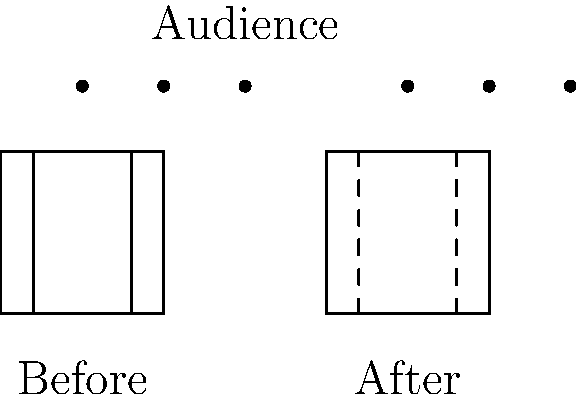Analyze the impact of minimalist set design on the audience's perception of Shakespeare's "Romeo and Juliet". How might the transition from a detailed, period-accurate set (left) to a stripped-down, suggestive design (right) alter the audience's engagement with the play's themes and characters? Consider the potential loss of historical context and the shift in focus to the performers and dialogue. 1. Traditional Set Design (Before):
   - Detailed, period-accurate set with solid walls and defined spaces
   - Provides clear historical context and immersive environment
   - Supports audience's visual understanding of the play's setting

2. Minimalist Set Design (After):
   - Stripped-down design with suggestive, dashed lines
   - Removes specific historical markers and detailed scenery
   - Shifts focus to performers and dialogue

3. Impact on Audience Perception:
   a. Loss of Historical Context:
      - Reduced visual cues may disconnect audience from specific time period
      - Could potentially universalize the story, making it feel more timeless

   b. Increased Focus on Performers:
      - Less visual distraction allows for greater attention to actors
      - May enhance audience's engagement with character emotions and relationships

   c. Emphasis on Dialogue:
      - Minimalist design puts more weight on the spoken word
      - Could heighten audience's attention to Shakespeare's language and poetic devices

   d. Imagination and Interpretation:
      - Sparse set may require audience to fill in gaps with their imagination
      - Could lead to more personal and varied interpretations of the play

   e. Thematic Focus:
      - Removal of period-specific elements might emphasize universal themes
      - Could potentially make the play's messages feel more relevant to contemporary audiences

4. Potential Drawbacks:
   - Risk of losing the play's intended historical and cultural specificity
   - May alienate traditionalist audiences expecting a more conventional presentation

5. Overall Effect:
   - Minimalist design likely shifts the audience's perception from a visually rich, historically grounded experience to a more abstract, text-focused interpretation of the classic play.
Answer: Minimalist design shifts focus from historical context to universal themes and performances, potentially enhancing engagement with dialogue but risking loss of period authenticity. 